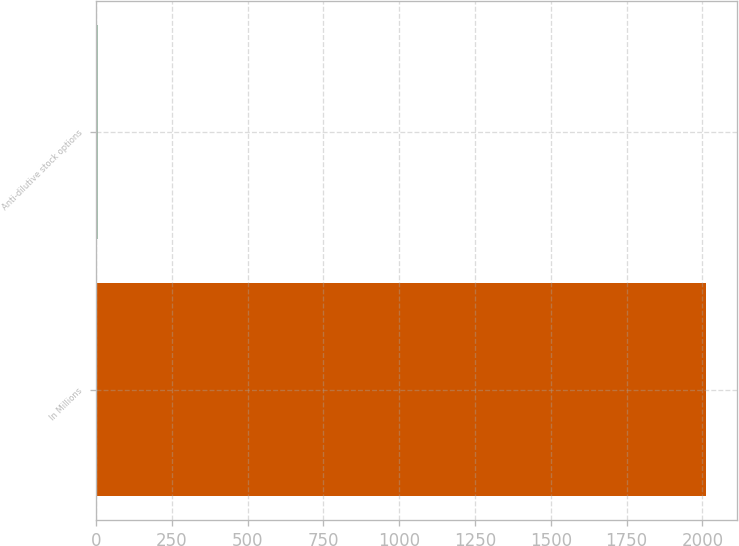Convert chart to OTSL. <chart><loc_0><loc_0><loc_500><loc_500><bar_chart><fcel>In Millions<fcel>Anti-dilutive stock options<nl><fcel>2012<fcel>5.8<nl></chart> 